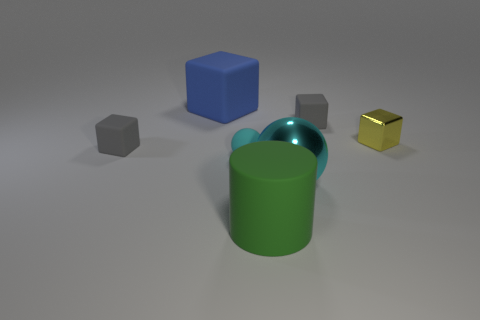Subtract all gray cubes. How many were subtracted if there are1gray cubes left? 1 Subtract 1 cubes. How many cubes are left? 3 Add 2 blue rubber cubes. How many objects exist? 9 Subtract all cylinders. How many objects are left? 6 Add 4 gray matte cubes. How many gray matte cubes exist? 6 Subtract 0 purple spheres. How many objects are left? 7 Subtract all matte things. Subtract all green matte cylinders. How many objects are left? 1 Add 5 small yellow metal objects. How many small yellow metal objects are left? 6 